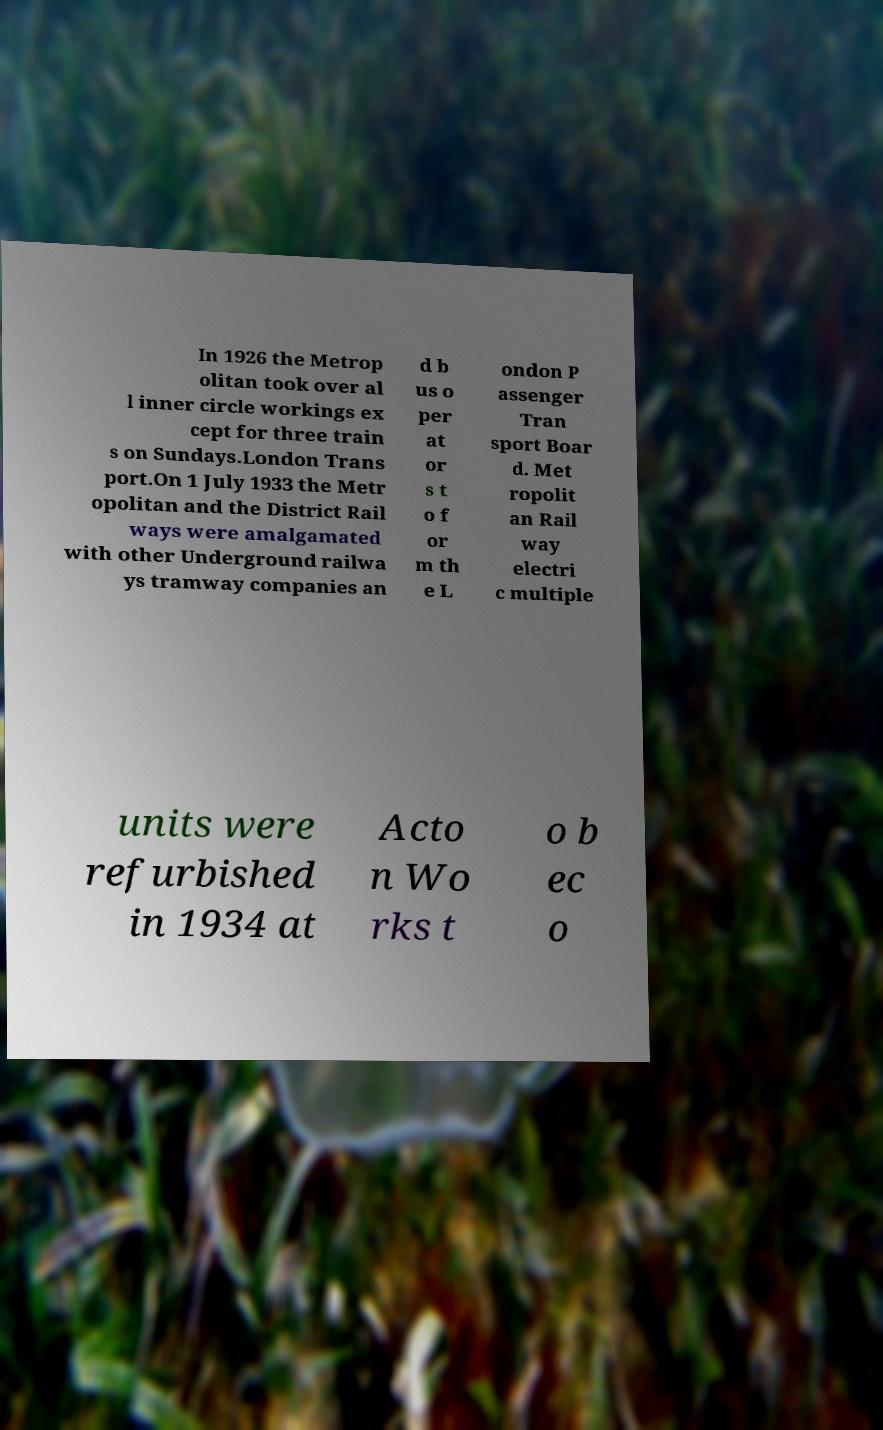Can you read and provide the text displayed in the image?This photo seems to have some interesting text. Can you extract and type it out for me? In 1926 the Metrop olitan took over al l inner circle workings ex cept for three train s on Sundays.London Trans port.On 1 July 1933 the Metr opolitan and the District Rail ways were amalgamated with other Underground railwa ys tramway companies an d b us o per at or s t o f or m th e L ondon P assenger Tran sport Boar d. Met ropolit an Rail way electri c multiple units were refurbished in 1934 at Acto n Wo rks t o b ec o 